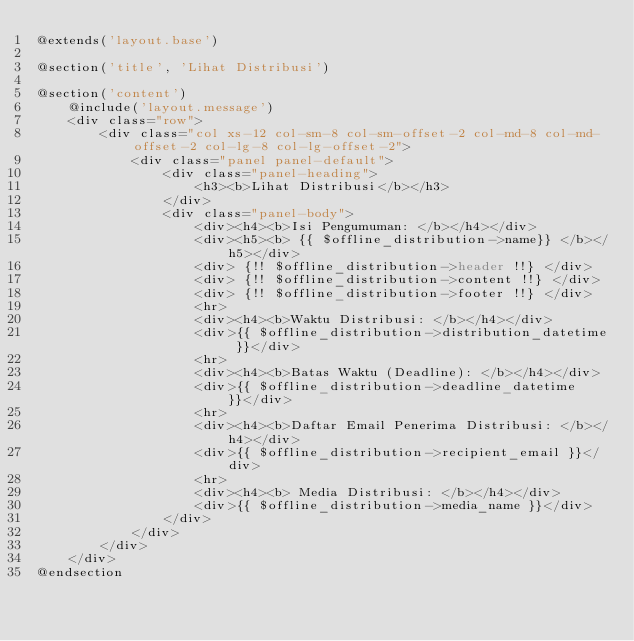<code> <loc_0><loc_0><loc_500><loc_500><_PHP_>@extends('layout.base')

@section('title', 'Lihat Distribusi')

@section('content')
    @include('layout.message')
    <div class="row">
        <div class="col xs-12 col-sm-8 col-sm-offset-2 col-md-8 col-md-offset-2 col-lg-8 col-lg-offset-2">
            <div class="panel panel-default">
                <div class="panel-heading">
                    <h3><b>Lihat Distribusi</b></h3>
                </div>
                <div class="panel-body">
                    <div><h4><b>Isi Pengumuman: </b></h4></div>
                    <div><h5><b> {{ $offline_distribution->name}} </b></h5></div>
                    <div> {!! $offline_distribution->header !!} </div>
                    <div> {!! $offline_distribution->content !!} </div>
                    <div> {!! $offline_distribution->footer !!} </div>
                    <hr>
                    <div><h4><b>Waktu Distribusi: </b></h4></div>
                    <div>{{ $offline_distribution->distribution_datetime }}</div>
                    <hr>
                    <div><h4><b>Batas Waktu (Deadline): </b></h4></div>
                    <div>{{ $offline_distribution->deadline_datetime }}</div>
                    <hr>
                    <div><h4><b>Daftar Email Penerima Distribusi: </b></h4></div>
                    <div>{{ $offline_distribution->recipient_email }}</div>
                    <hr>
                    <div><h4><b> Media Distribusi: </b></h4></div>
                    <div>{{ $offline_distribution->media_name }}</div>
                </div>
            </div>
        </div>
    </div>
@endsection
</code> 